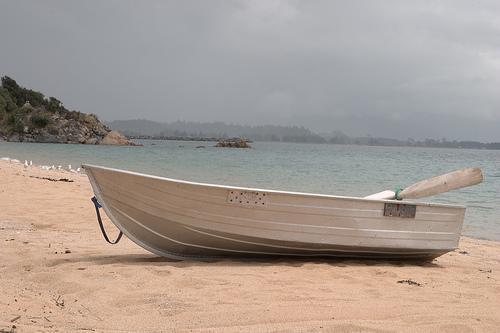How many birds are there in the picture?
Give a very brief answer. 6. 